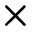<formula> <loc_0><loc_0><loc_500><loc_500>\times</formula> 